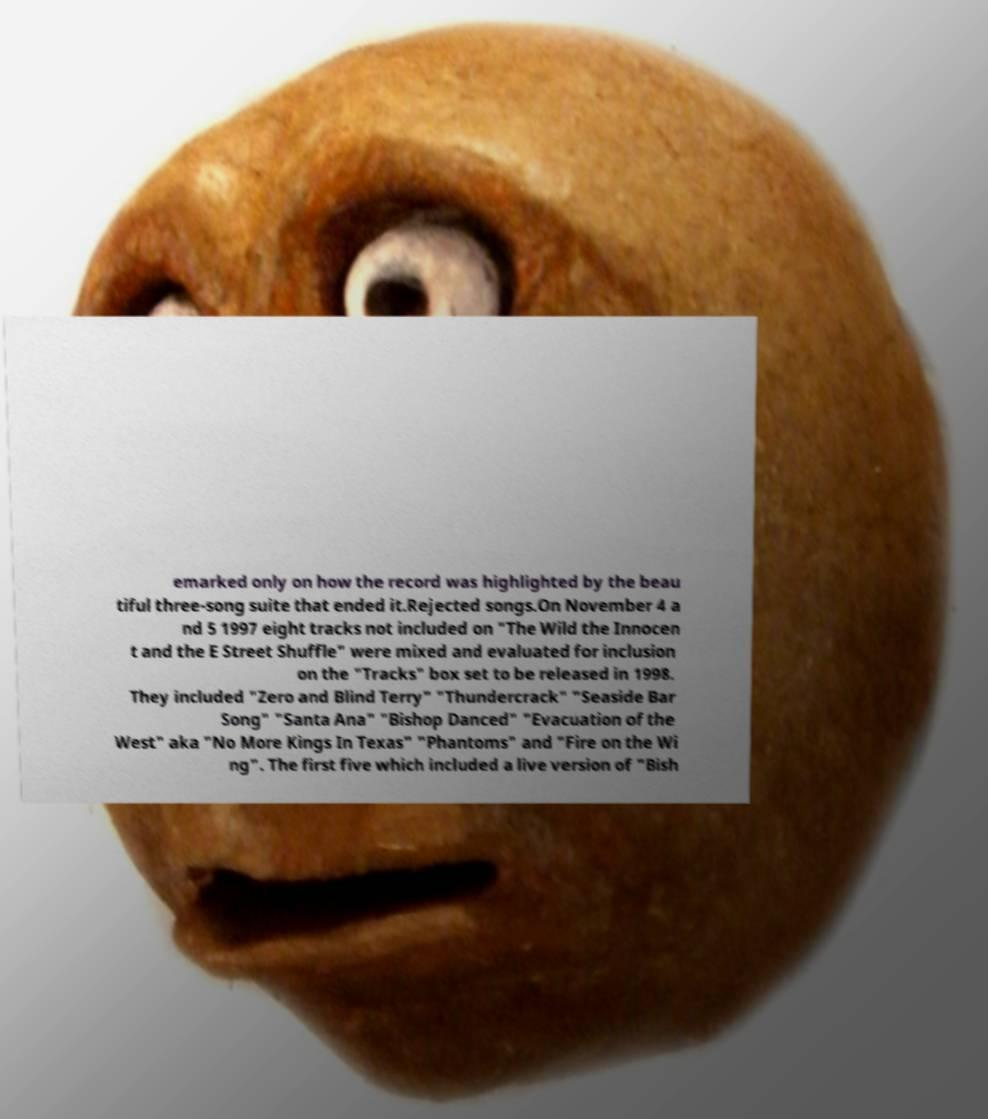Could you assist in decoding the text presented in this image and type it out clearly? emarked only on how the record was highlighted by the beau tiful three-song suite that ended it.Rejected songs.On November 4 a nd 5 1997 eight tracks not included on "The Wild the Innocen t and the E Street Shuffle" were mixed and evaluated for inclusion on the "Tracks" box set to be released in 1998. They included "Zero and Blind Terry" "Thundercrack" "Seaside Bar Song" "Santa Ana" "Bishop Danced" "Evacuation of the West" aka "No More Kings In Texas" "Phantoms" and "Fire on the Wi ng". The first five which included a live version of "Bish 